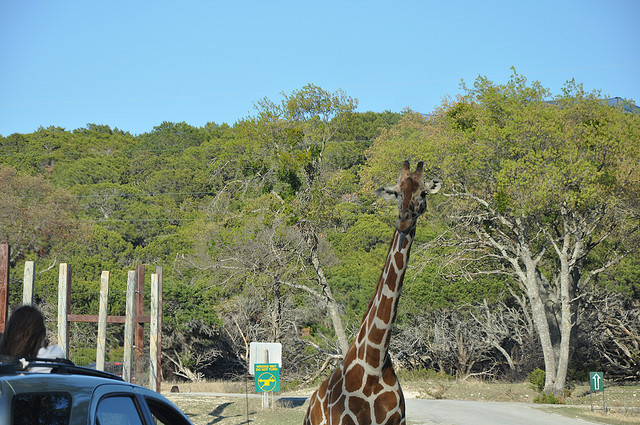<image>What is cast? The cast is unknown. It could be shadows from wooden posts, a giraffe, or a tree. What is cast? I don't know what cast refers to in this context. It is unclear from the given answers. 